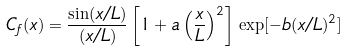Convert formula to latex. <formula><loc_0><loc_0><loc_500><loc_500>C _ { f } ( x ) = \frac { \sin ( x / L ) } { ( x / L ) } \left [ 1 + a \left ( \frac { x } { L } \right ) ^ { 2 } \right ] \, \exp [ - b ( x / L ) ^ { 2 } ]</formula> 